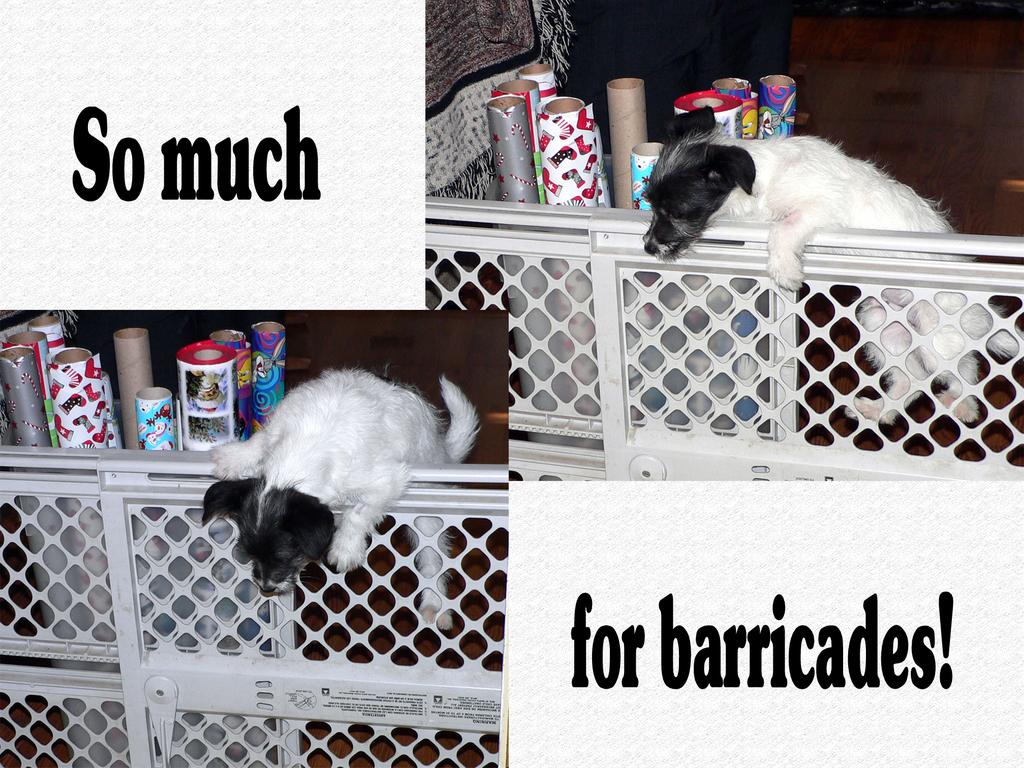What animals are on the fence in the image? There are dogs on the fence in the image. What can be seen on the white color board? There are objects and text on the white color board. What is the color of the cloth in the image? The color of the cloth in the image is not specified, but it is mentioned that there is a cloth present. How does the guide help the dogs cross the street in the image? There is no guide or indication of crossing a street in the image; it features dogs on a fence and objects on a white color board. 